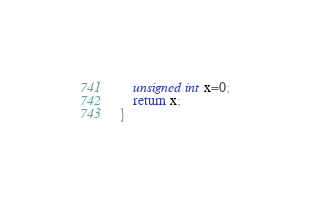<code> <loc_0><loc_0><loc_500><loc_500><_C++_>	unsigned int x=0;
	return x;
}
</code> 